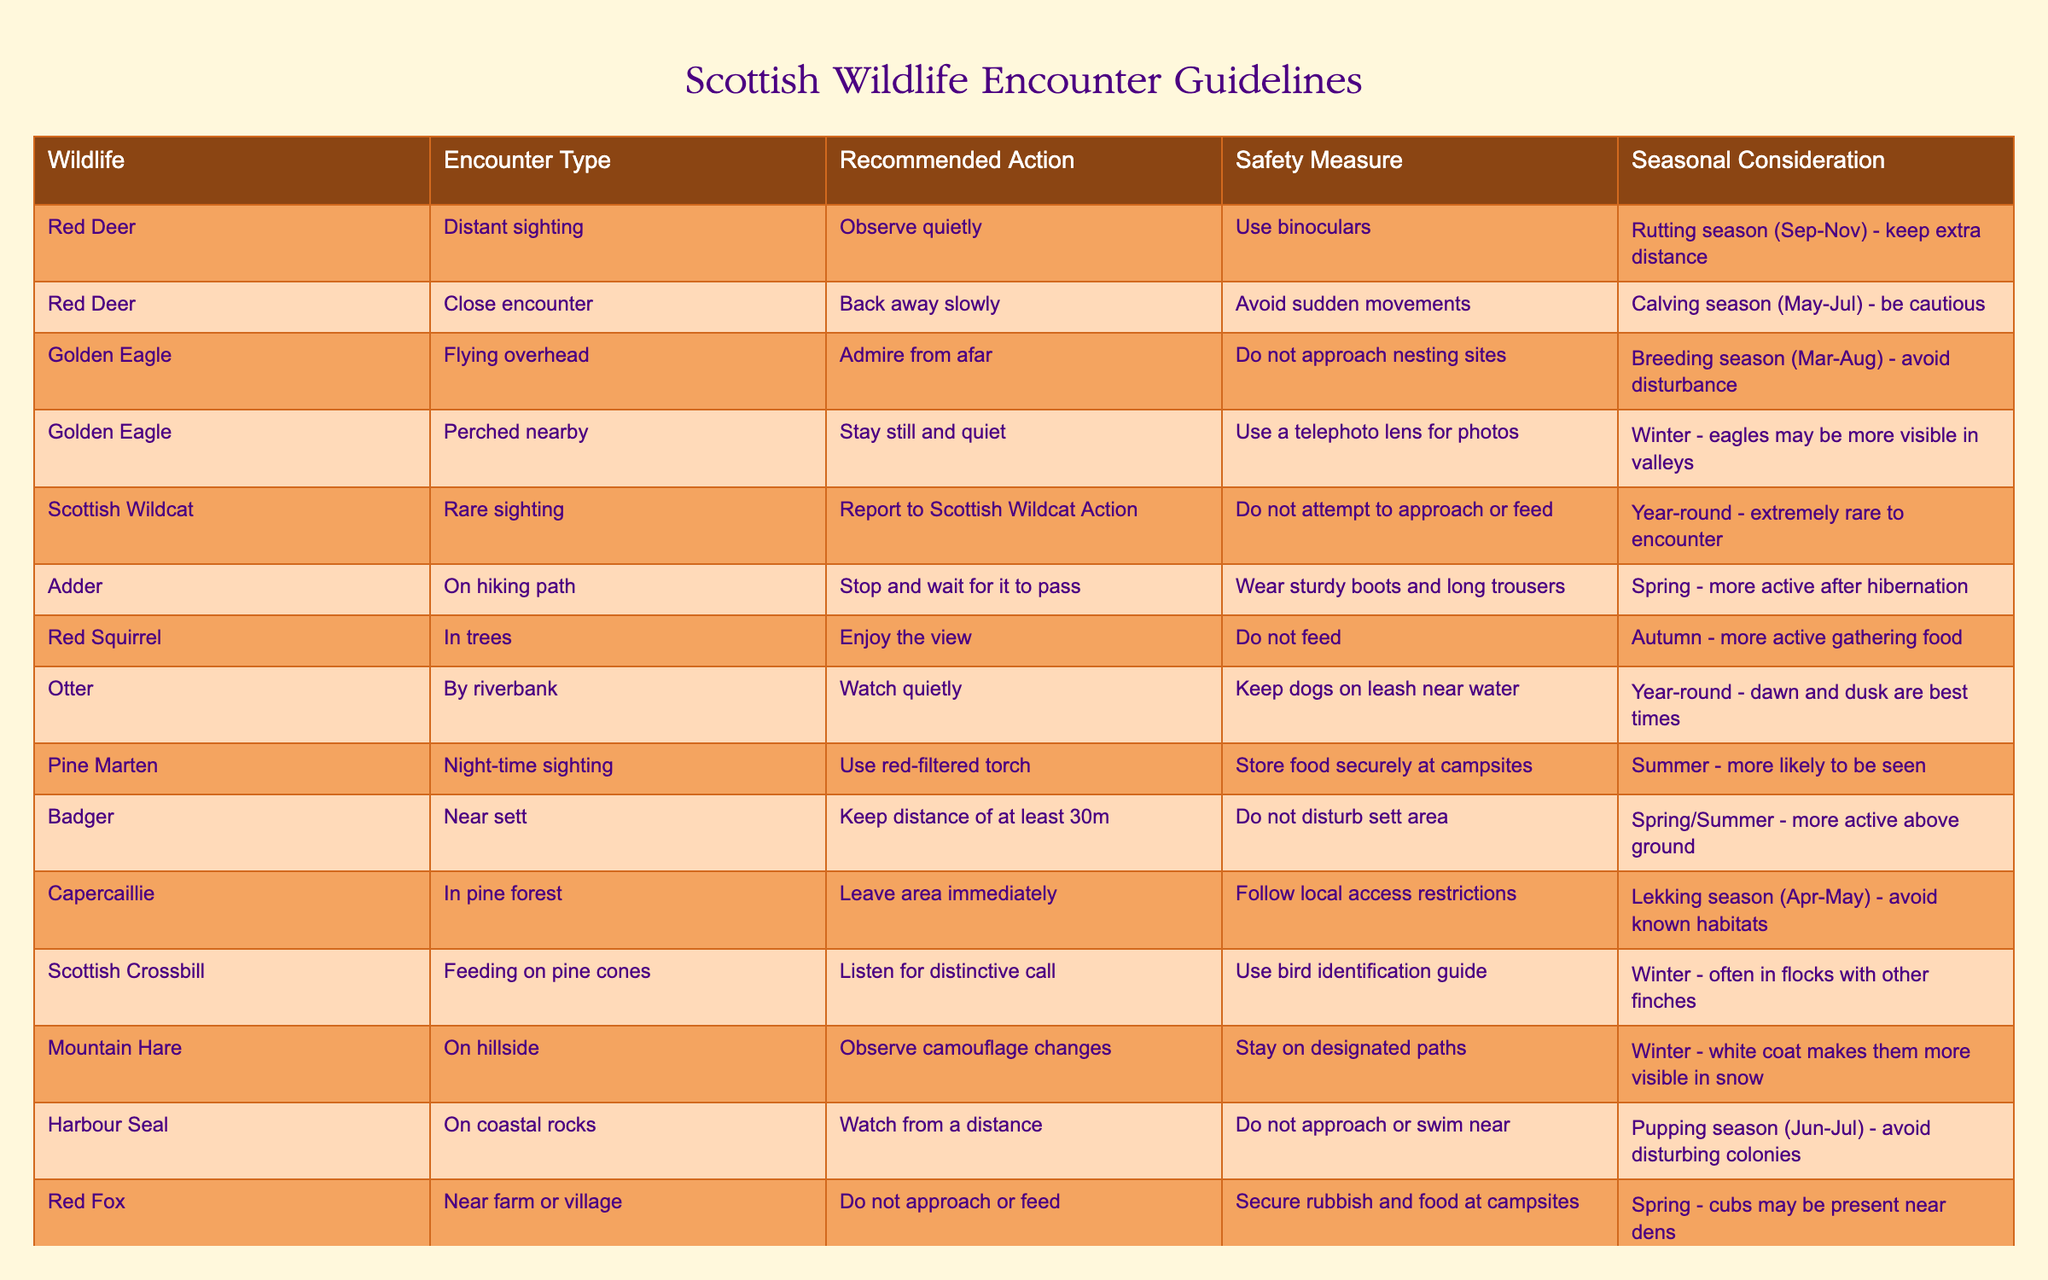What is the recommended action when encountering a Red Deer at a close distance? The table clearly states that during a close encounter with a Red Deer, the recommended action is to "Back away slowly." This can be found in the row associated with the Red Deer under the Encounter Type "Close encounter."
Answer: Back away slowly During which season should one be cautious when encountering Red Deer due to calving? The table indicates that calving season occurs from May to July, and caution should be exercised during this time especially in close encounters with Red Deer. This information is found in the Seasonal Consideration column for the Red Deer.
Answer: May to July How many species in the table require avoiding disturbance during their breeding or nesting season? By examining the table, we can find that both Golden Eagle and Harbour Seal have recommendations to avoid disturbance during their breeding/nesting times. The Golden Eagle is in the breeding season from March to August and the Harbour Seal during the pupping season in June to July. Hence, there are two species that have such recommendations.
Answer: 2 Is it true that one should use a telephoto lens for photos when observing a Golden Eagle perched nearby? Yes, according to the table, when a Golden Eagle is perched nearby, the safety measure is specifically to "Use a telephoto lens for photos," indicating that this is correct.
Answer: Yes What should you do if you spot a Scottish Wildcat? When encountering a Scottish Wildcat, the table states to "Report to Scottish Wildcat Action" as the recommended action. This is indicated under the row for Scottish Wildcat in the Recommended Action column.
Answer: Report to Scottish Wildcat Action Which encounter type for the Adder suggests waiting for it to pass and why? The table shows that if you see an Adder on a hiking path, the recommended action is to "Stop and wait for it to pass." This is because approaching could be dangerous, and waiting ensures safety without sudden movements. The seasonal consideration notes that Adders are more active in spring.
Answer: On hiking path Identify one wildlife species that requires you to keep your distance during the active months and provide that distance. The Badger row in the table indicates that a distance of at least 30 meters should be maintained when near a Badger during spring/summer since they are more active above ground at this time.
Answer: 30 meters What is the unique seasonal consideration for observing the Mountain Hare on a hillside? The unique seasonal consideration for the Mountain Hare is that in winter, the hare's white coat makes them more visible in the snow. This note can be found in the Seasonal Consideration column associated with the Mountain Hare entry.
Answer: Winter 